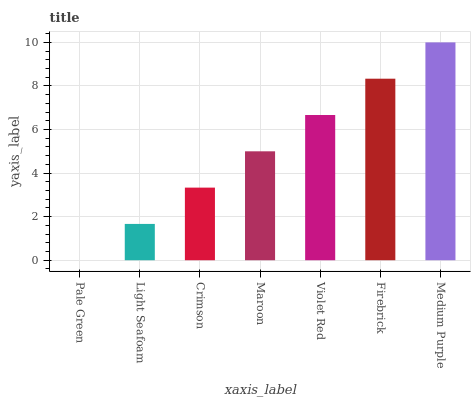Is Pale Green the minimum?
Answer yes or no. Yes. Is Medium Purple the maximum?
Answer yes or no. Yes. Is Light Seafoam the minimum?
Answer yes or no. No. Is Light Seafoam the maximum?
Answer yes or no. No. Is Light Seafoam greater than Pale Green?
Answer yes or no. Yes. Is Pale Green less than Light Seafoam?
Answer yes or no. Yes. Is Pale Green greater than Light Seafoam?
Answer yes or no. No. Is Light Seafoam less than Pale Green?
Answer yes or no. No. Is Maroon the high median?
Answer yes or no. Yes. Is Maroon the low median?
Answer yes or no. Yes. Is Pale Green the high median?
Answer yes or no. No. Is Pale Green the low median?
Answer yes or no. No. 